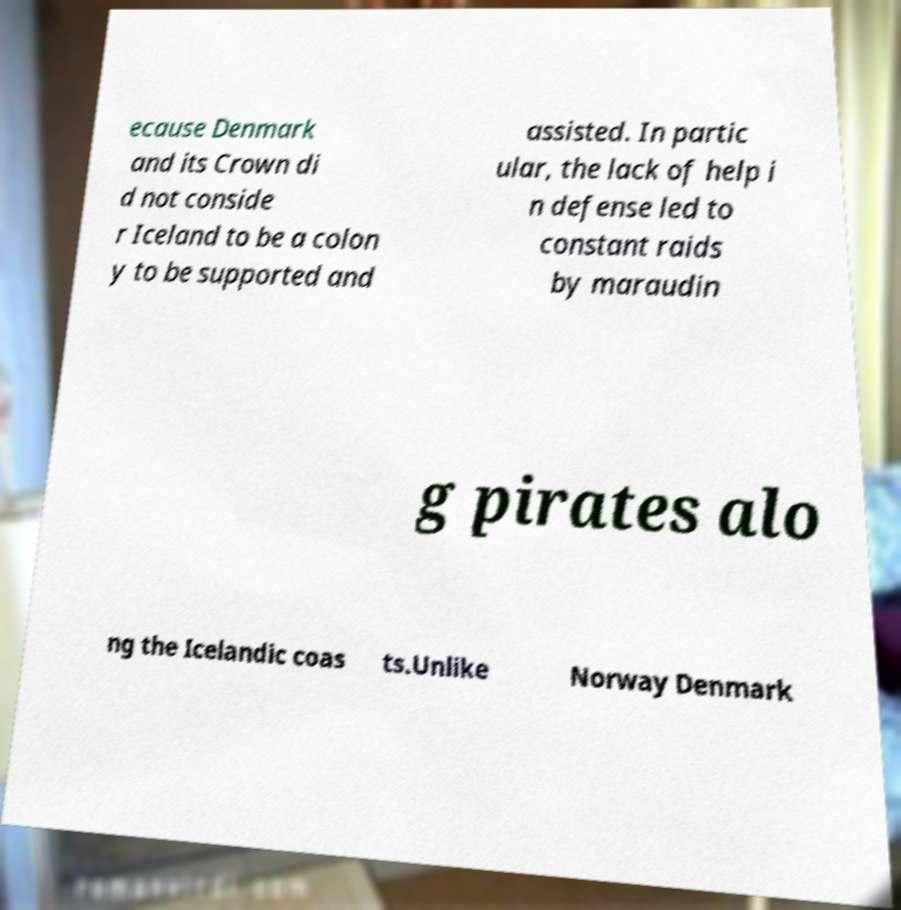For documentation purposes, I need the text within this image transcribed. Could you provide that? ecause Denmark and its Crown di d not conside r Iceland to be a colon y to be supported and assisted. In partic ular, the lack of help i n defense led to constant raids by maraudin g pirates alo ng the Icelandic coas ts.Unlike Norway Denmark 